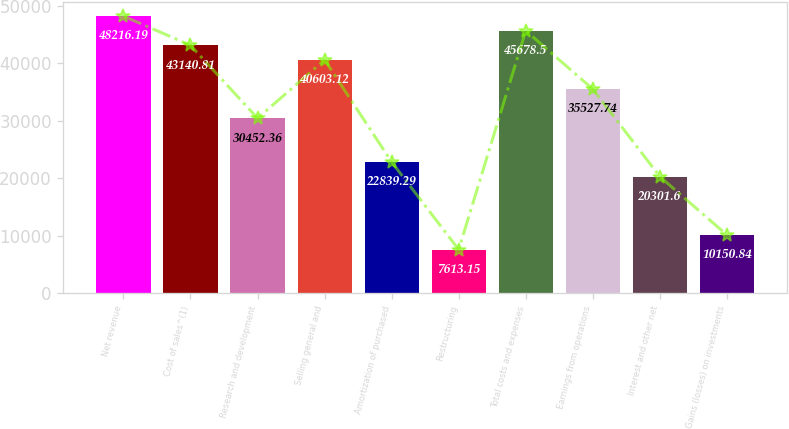<chart> <loc_0><loc_0><loc_500><loc_500><bar_chart><fcel>Net revenue<fcel>Cost of sales^(1)<fcel>Research and development<fcel>Selling general and<fcel>Amortization of purchased<fcel>Restructuring<fcel>Total costs and expenses<fcel>Earnings from operations<fcel>Interest and other net<fcel>Gains (losses) on investments<nl><fcel>48216.2<fcel>43140.8<fcel>30452.4<fcel>40603.1<fcel>22839.3<fcel>7613.15<fcel>45678.5<fcel>35527.7<fcel>20301.6<fcel>10150.8<nl></chart> 